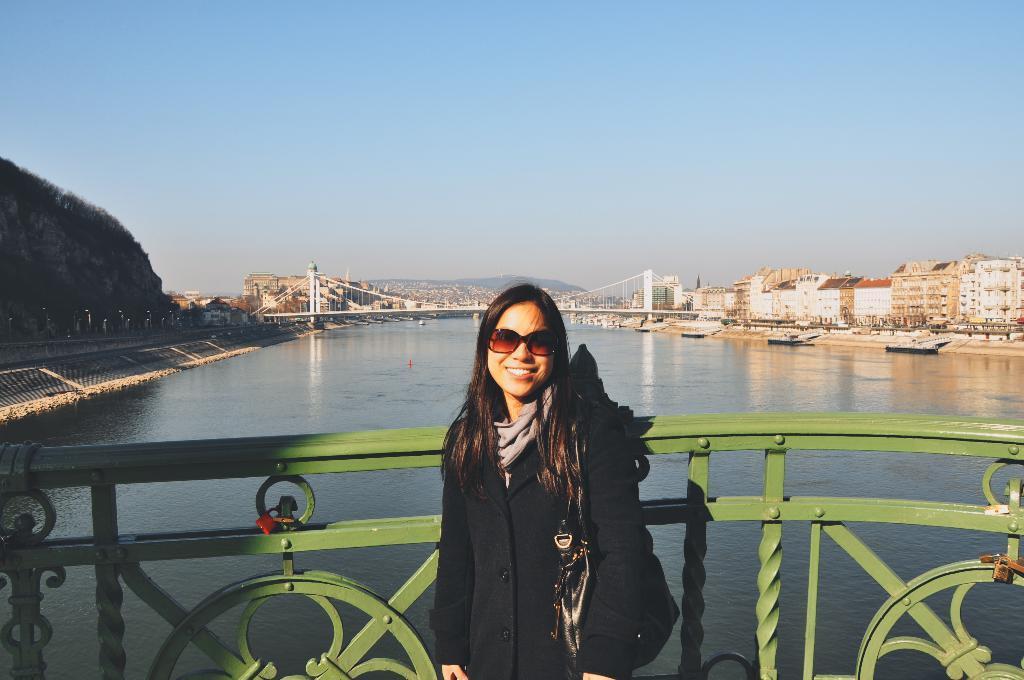Describe this image in one or two sentences. In the middle of the image a woman is standing and smiling. Behind her there is a fencing. Behind the fencing there is water and there is a bridge. Behind the bridge there are some trees and buildings. Above the water there are some ships. At the top of the image there is sky. 